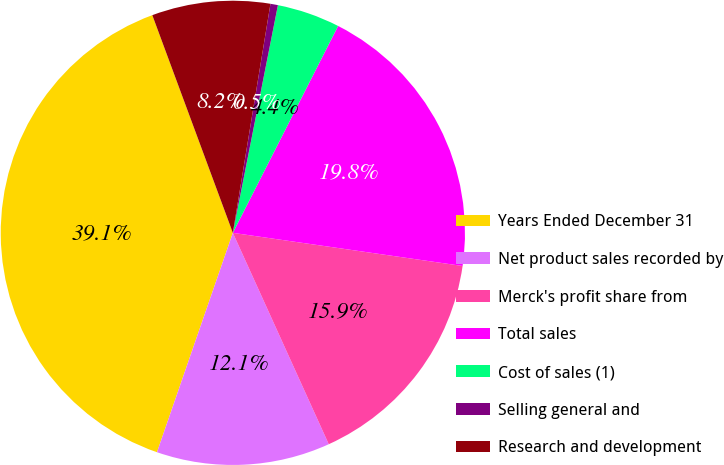Convert chart. <chart><loc_0><loc_0><loc_500><loc_500><pie_chart><fcel>Years Ended December 31<fcel>Net product sales recorded by<fcel>Merck's profit share from<fcel>Total sales<fcel>Cost of sales (1)<fcel>Selling general and<fcel>Research and development<nl><fcel>39.06%<fcel>12.08%<fcel>15.94%<fcel>19.79%<fcel>4.38%<fcel>0.52%<fcel>8.23%<nl></chart> 